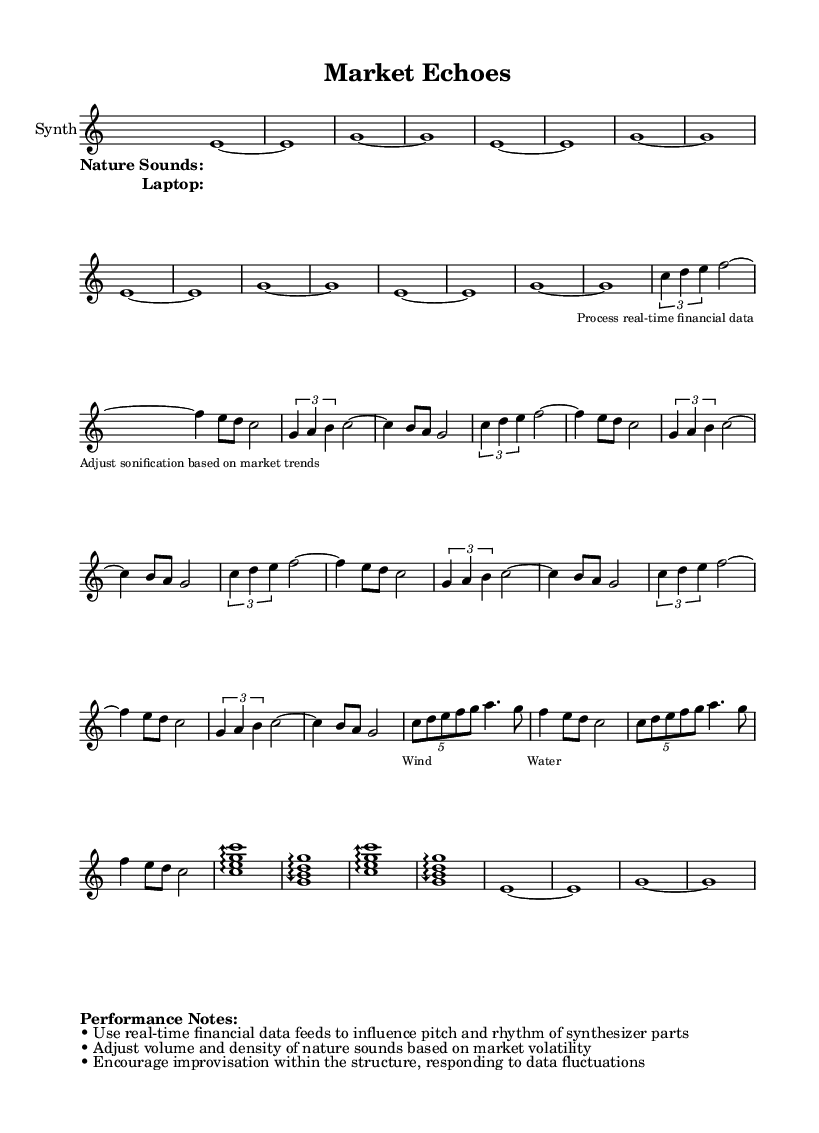What is the time signature of this music? The time signature is 4/4, which is indicated at the beginning of the synthesizer part.
Answer: 4/4 What instrument is featured in this score? The instrument is labeled as "Synth" in the staff.
Answer: Synth How many measures are repeated in the intro? The intro consists of 4 measures, as indicated by the repeat notation before the introductory section.
Answer: 4 What is the structure of the climax section in terms of chord progressions? The climax consists of two arpeggiated chords, C major and G major, indicated by the arpeggio symbols in that section.
Answer: C major and G major What is the primary theme conveyed through the lyrics of the field recordings? The field recordings lyrics suggest the concept of nature sounds, especially wind and water, which appear prominently in the background.
Answer: Nature Sounds How often does the phrase "Process real-time financial data" appear in the laptop lyrics? The phrase appears once, as the lyrics specifically state it within the section.
Answer: Once What are the performance notes regarding market volatility? The performance notes indicate that the volume and density of nature sounds should adjust based on market volatility, providing guidelines for real-time sound adaptation.
Answer: Adjust volume and density 